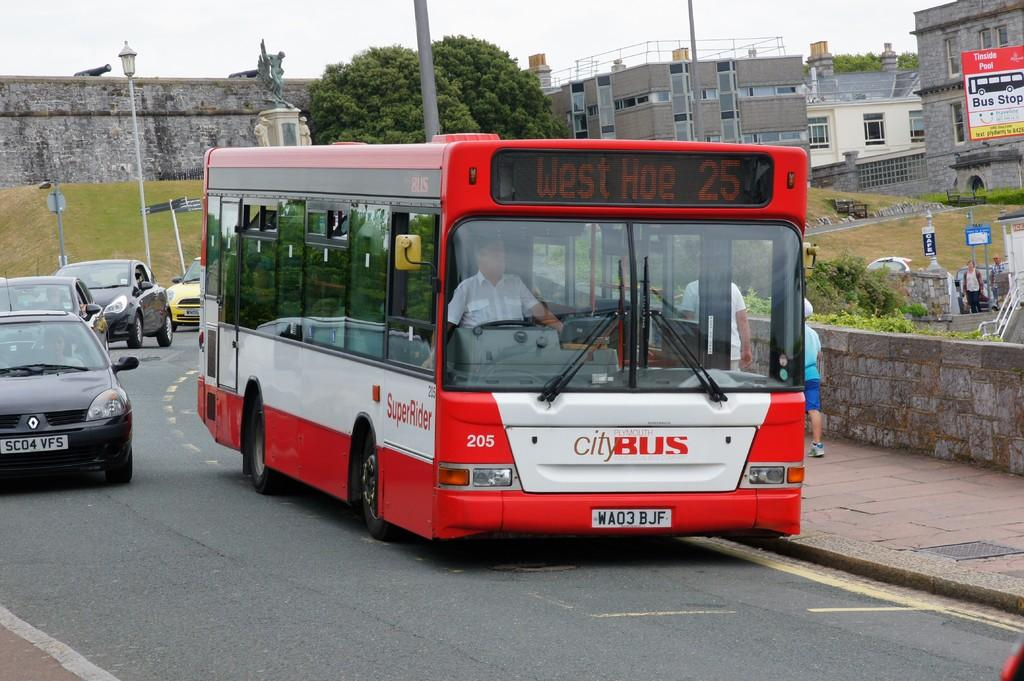<image>
Give a short and clear explanation of the subsequent image. A red and white City Bus drives to West Hoe 25. 